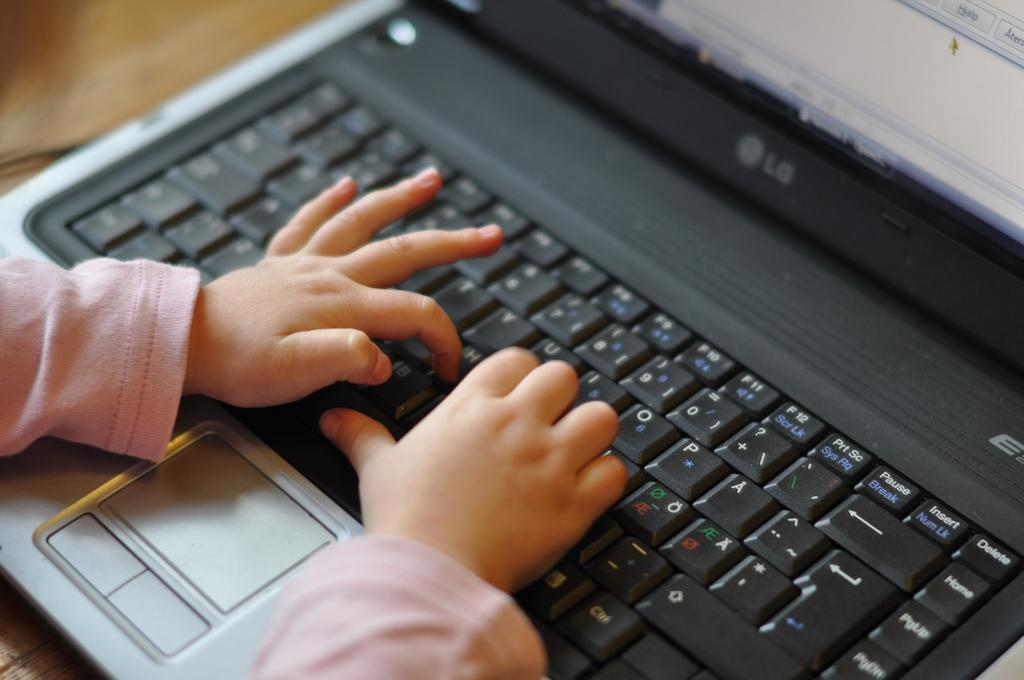Provide a one-sentence caption for the provided image. A baby types on a laptop keyboard by pressing the 'H' button. 